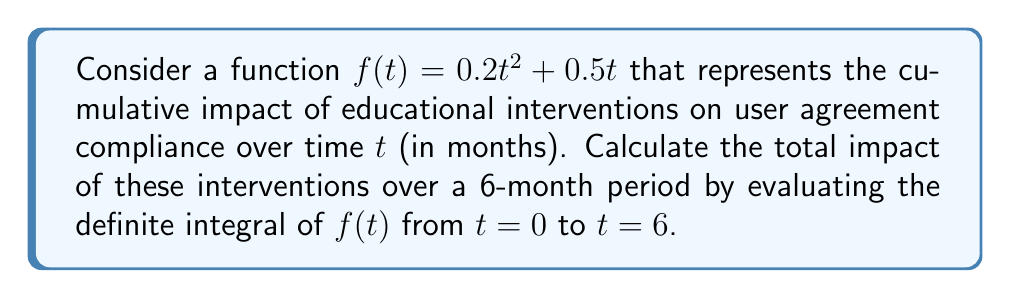Give your solution to this math problem. To solve this problem, we need to evaluate the definite integral of $f(t) = 0.2t^2 + 0.5t$ from $t=0$ to $t=6$. Let's break it down step-by-step:

1) The definite integral is given by:

   $$\int_0^6 (0.2t^2 + 0.5t) dt$$

2) To integrate, we apply the power rule for each term:
   - For $0.2t^2$: $\int 0.2t^2 dt = 0.2 \cdot \frac{t^3}{3} = \frac{0.2t^3}{3}$
   - For $0.5t$: $\int 0.5t dt = 0.5 \cdot \frac{t^2}{2} = \frac{0.25t^2}{1}$

3) The antiderivative is:

   $$F(t) = \frac{0.2t^3}{3} + 0.25t^2 + C$$

4) Now, we apply the Fundamental Theorem of Calculus:

   $$\int_0^6 f(t) dt = F(6) - F(0)$$

5) Let's calculate $F(6)$ and $F(0)$:
   
   $F(6) = \frac{0.2(6^3)}{3} + 0.25(6^2) = 14.4 + 9 = 23.4$
   
   $F(0) = \frac{0.2(0^3)}{3} + 0.25(0^2) = 0$

6) Therefore, the definite integral is:

   $$F(6) - F(0) = 23.4 - 0 = 23.4$$

This result represents the total impact of the educational interventions on user agreement compliance over the 6-month period.
Answer: 23.4 